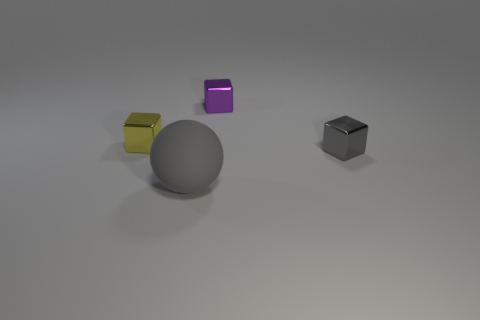Add 1 large gray objects. How many objects exist? 5 Subtract all tiny metal cylinders. Subtract all big matte spheres. How many objects are left? 3 Add 2 purple objects. How many purple objects are left? 3 Add 4 large yellow metal spheres. How many large yellow metal spheres exist? 4 Subtract 0 green cubes. How many objects are left? 4 Subtract all balls. How many objects are left? 3 Subtract all cyan cubes. Subtract all green spheres. How many cubes are left? 3 Subtract all gray spheres. How many yellow cubes are left? 1 